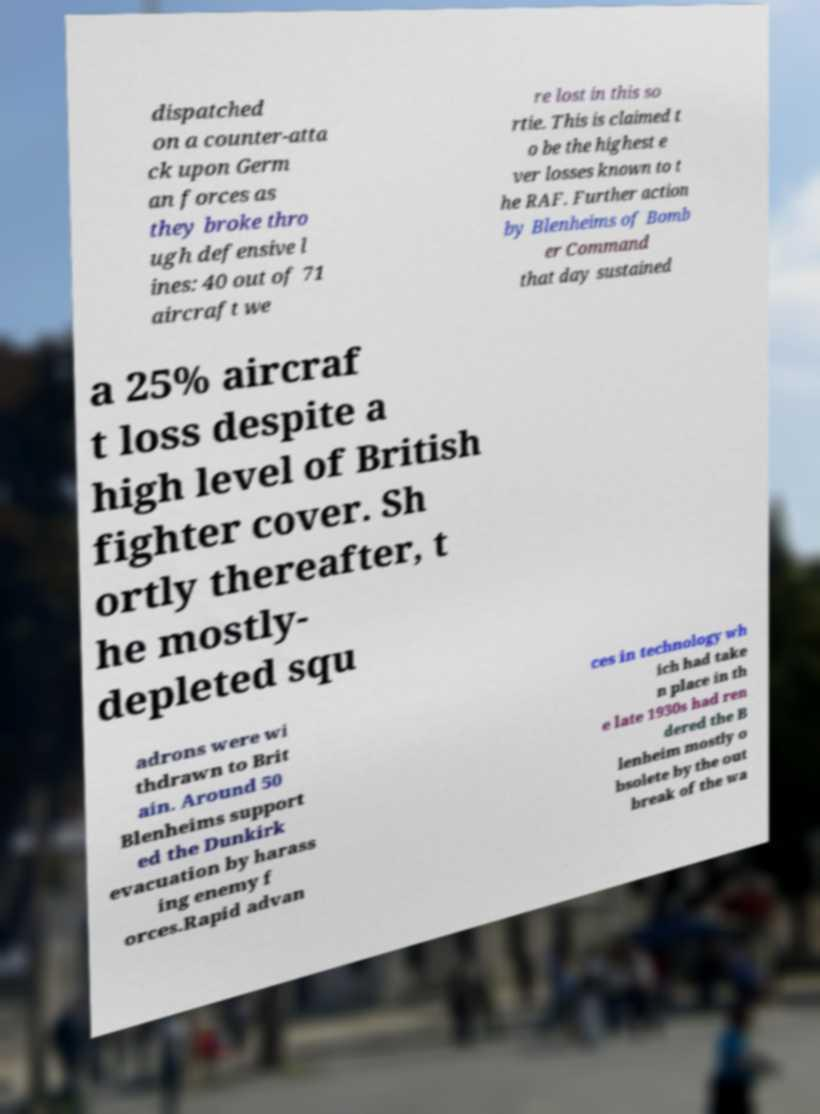Could you assist in decoding the text presented in this image and type it out clearly? dispatched on a counter-atta ck upon Germ an forces as they broke thro ugh defensive l ines: 40 out of 71 aircraft we re lost in this so rtie. This is claimed t o be the highest e ver losses known to t he RAF. Further action by Blenheims of Bomb er Command that day sustained a 25% aircraf t loss despite a high level of British fighter cover. Sh ortly thereafter, t he mostly- depleted squ adrons were wi thdrawn to Brit ain. Around 50 Blenheims support ed the Dunkirk evacuation by harass ing enemy f orces.Rapid advan ces in technology wh ich had take n place in th e late 1930s had ren dered the B lenheim mostly o bsolete by the out break of the wa 